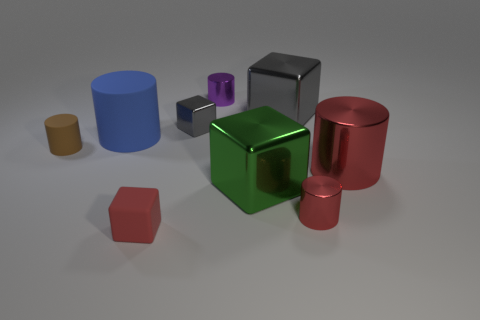Apart from the obvious geometric shapes, is there anything else unique about the arrangement of objects? Upon a closer observation, the arrangement of the objects seems intentional, with varying sizes and colors creating a visually interesting composition. The placement may have been designed to demonstrate perspective or to showcase how different shapes interact with light to create shadows. 